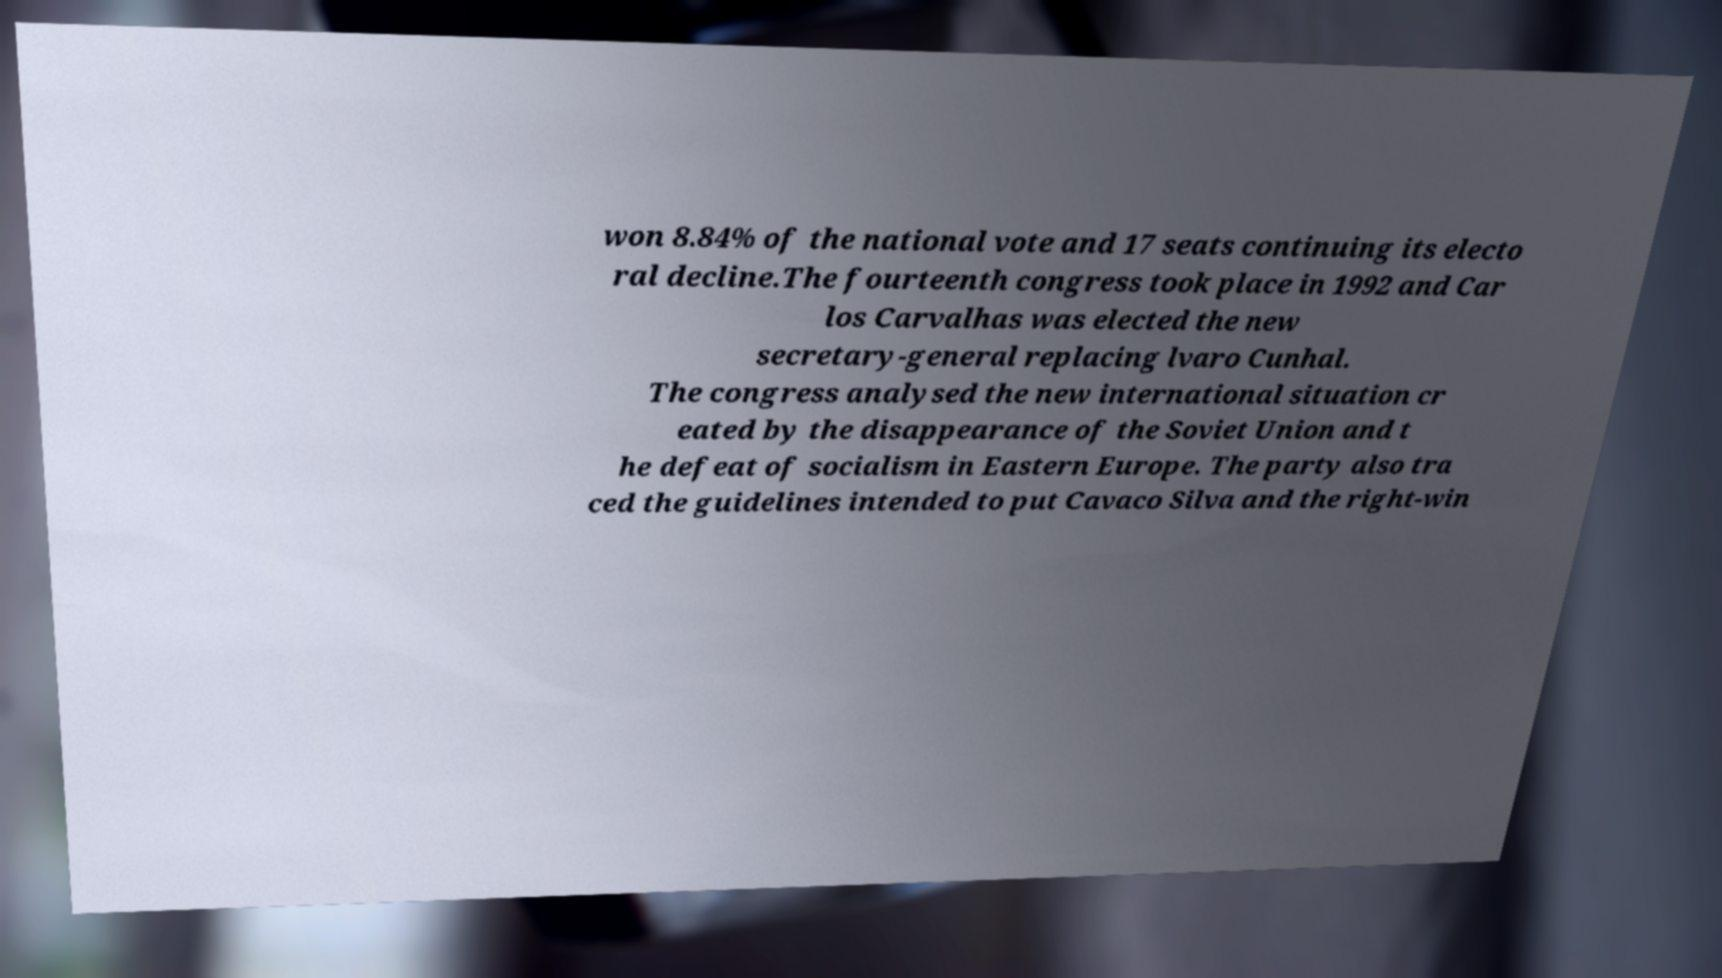What messages or text are displayed in this image? I need them in a readable, typed format. won 8.84% of the national vote and 17 seats continuing its electo ral decline.The fourteenth congress took place in 1992 and Car los Carvalhas was elected the new secretary-general replacing lvaro Cunhal. The congress analysed the new international situation cr eated by the disappearance of the Soviet Union and t he defeat of socialism in Eastern Europe. The party also tra ced the guidelines intended to put Cavaco Silva and the right-win 